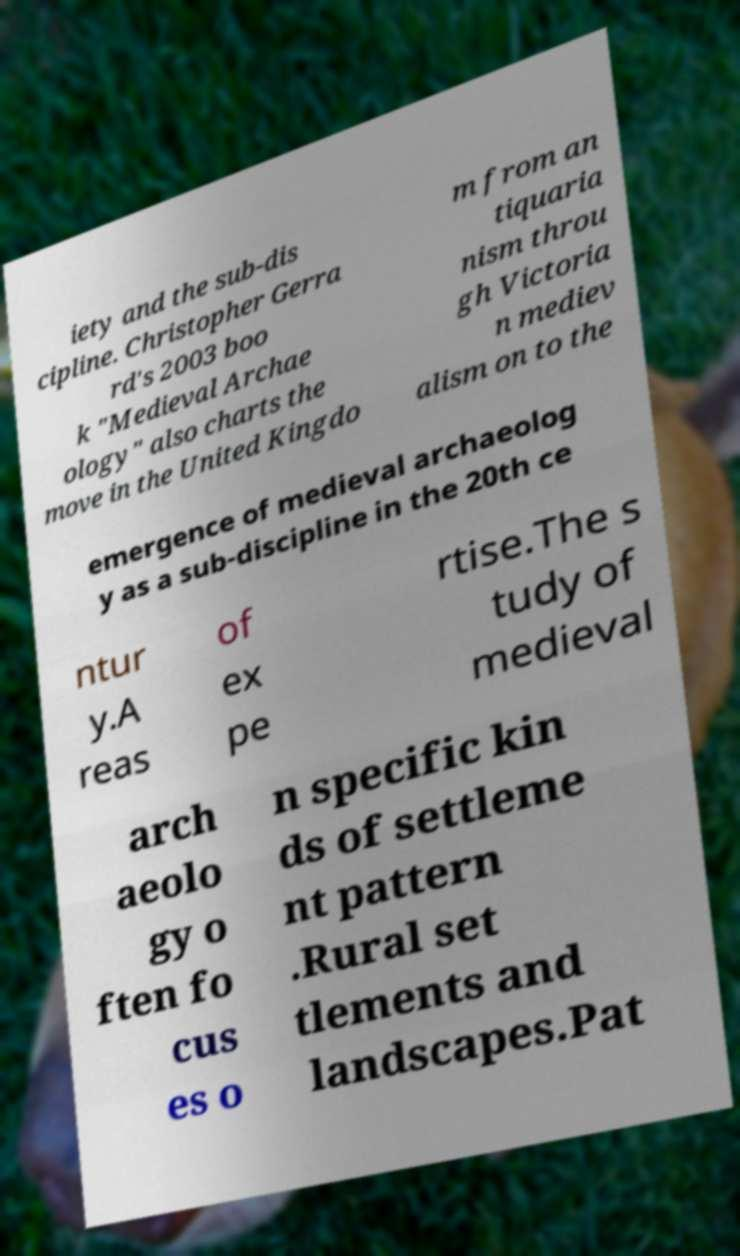What messages or text are displayed in this image? I need them in a readable, typed format. iety and the sub-dis cipline. Christopher Gerra rd's 2003 boo k "Medieval Archae ology" also charts the move in the United Kingdo m from an tiquaria nism throu gh Victoria n mediev alism on to the emergence of medieval archaeolog y as a sub-discipline in the 20th ce ntur y.A reas of ex pe rtise.The s tudy of medieval arch aeolo gy o ften fo cus es o n specific kin ds of settleme nt pattern .Rural set tlements and landscapes.Pat 